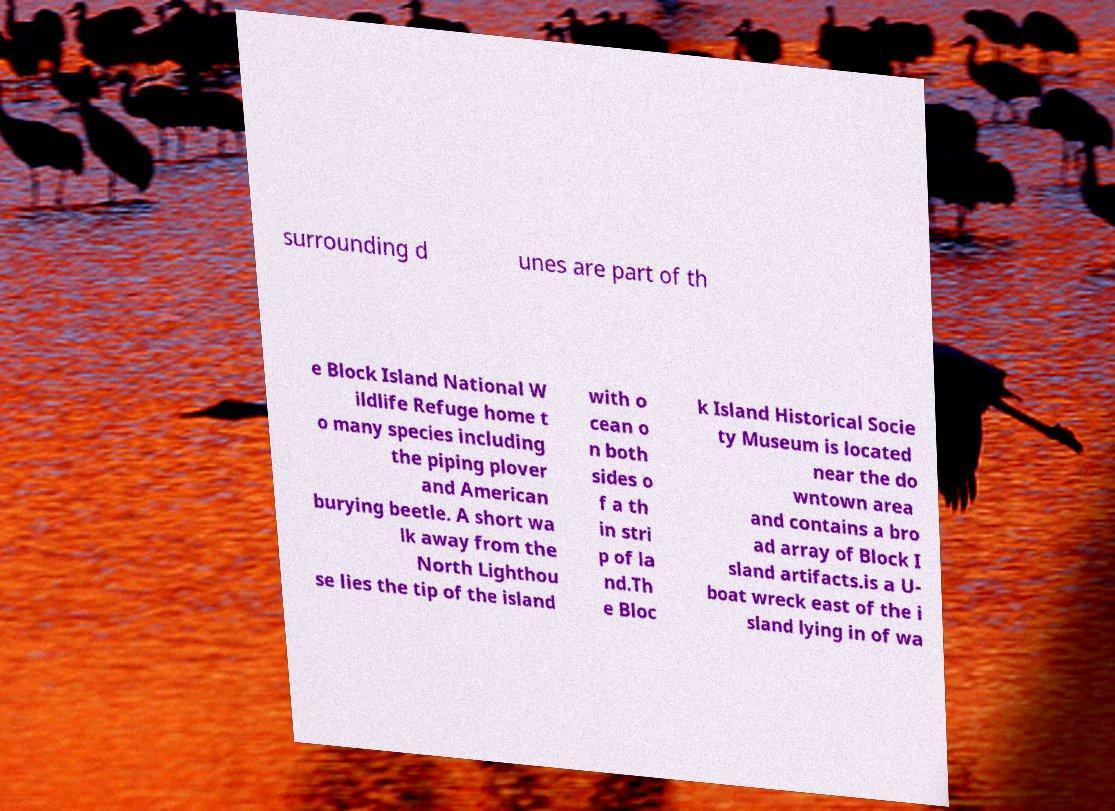Can you accurately transcribe the text from the provided image for me? surrounding d unes are part of th e Block Island National W ildlife Refuge home t o many species including the piping plover and American burying beetle. A short wa lk away from the North Lighthou se lies the tip of the island with o cean o n both sides o f a th in stri p of la nd.Th e Bloc k Island Historical Socie ty Museum is located near the do wntown area and contains a bro ad array of Block I sland artifacts.is a U- boat wreck east of the i sland lying in of wa 